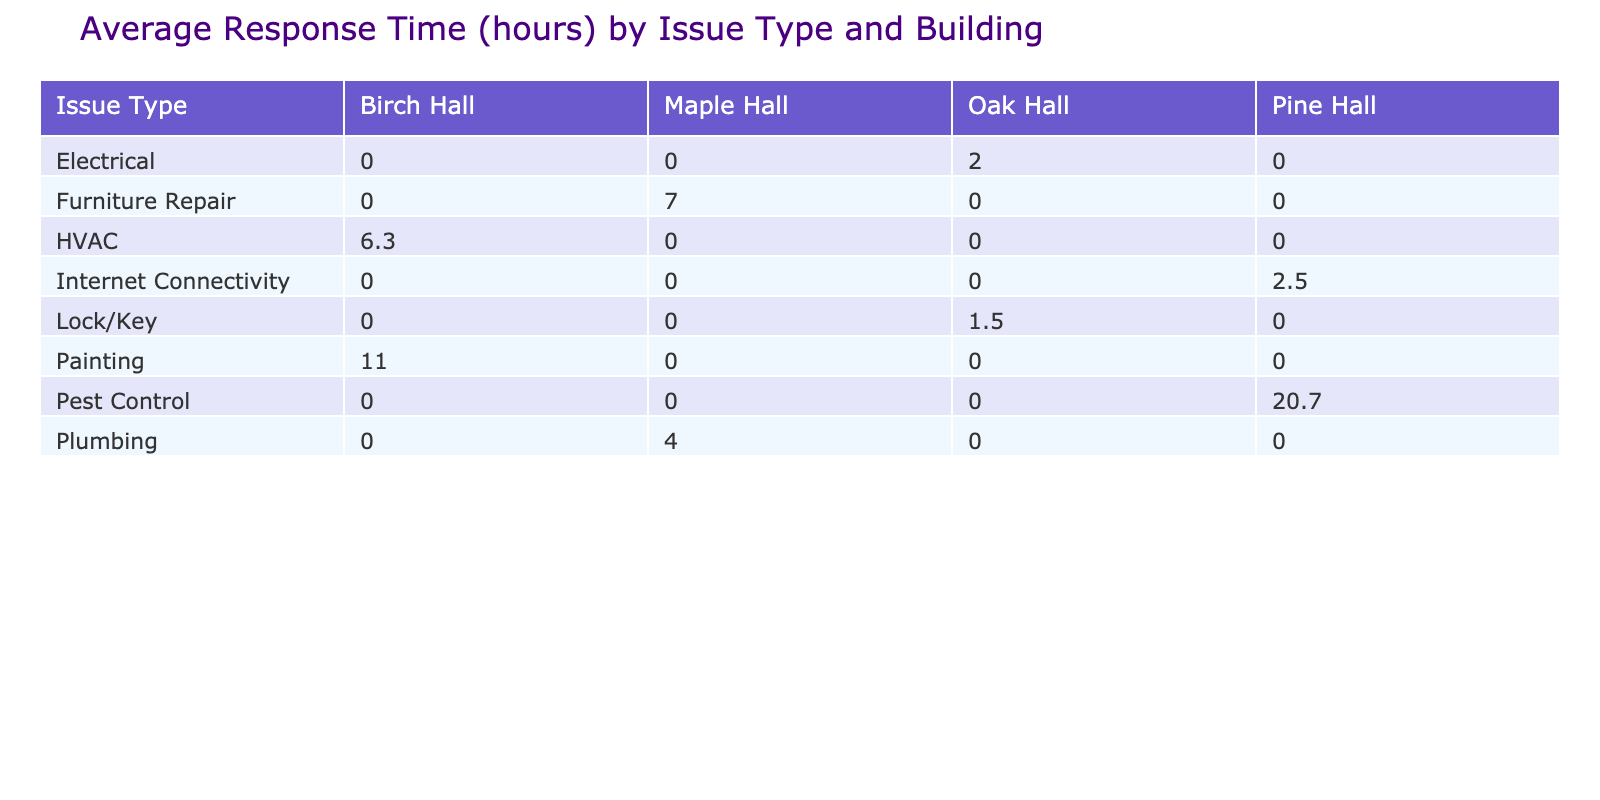What is the average response time for plumbing issues in Maple Hall? In the table, plumbing issues in Maple Hall have response times of 4, 5, and 3 hours. To find the average, add these times (4 + 5 + 3 = 12) and divide by the number of entries (12 / 3 = 4.0).
Answer: 4.0 Which building has the highest average response time across all issue types? Looking at the average response times for each building, calculate the averages: Maple Hall (4 + 8 + 6 + 3 = 21 / 4 = 5.3), Oak Hall (2 + 3 + 1 + 2 = 8 / 4 = 2.0), Birch Hall (6 + 8 + 10 = 24 / 3 = 8.0), Pine Hall (24 + 3 + 18 + 20 = 65 / 4 = 16.25). Pine Hall has the highest average.
Answer: Pine Hall Did any response times exceed 15 hours, and if so, which issue types were they? By examining the table, we see that Pest Control had response times of 24 hours (first entry) and 20 hours (last entry). These are the only instances exceeding 15 hours.
Answer: Yes, Pest Control What is the overall average response time for electrical issues? The response times for electrical issues are 2, 3, and 1 hours. Summing these gives (2 + 3 + 1 = 6). Dividing by the total number of entries (3) gives an average of (6 / 3 = 2.0).
Answer: 2.0 Is the average response time for HVAC issues greater than 5 hours? The response times for HVAC are 6, 8, and 5 hours. The average is calculated as (6 + 8 + 5 = 19 / 3 = 6.33). Since 6.33 is greater than 5, the answer is yes.
Answer: Yes What is the difference between the highest and lowest average response times among the issue types? Finding the averages for each issue type: Plumbing (4.0), Electrical (2.0), HVAC (6.3), Pest Control (20.5), Furniture Repair (7.0), Lock/Key (1.75), Internet Connectivity (2.5). The highest is 20.5 (Pest Control) and the lowest is 1.75 (Lock/Key). The difference is (20.5 - 1.75 = 18.75).
Answer: 18.75 